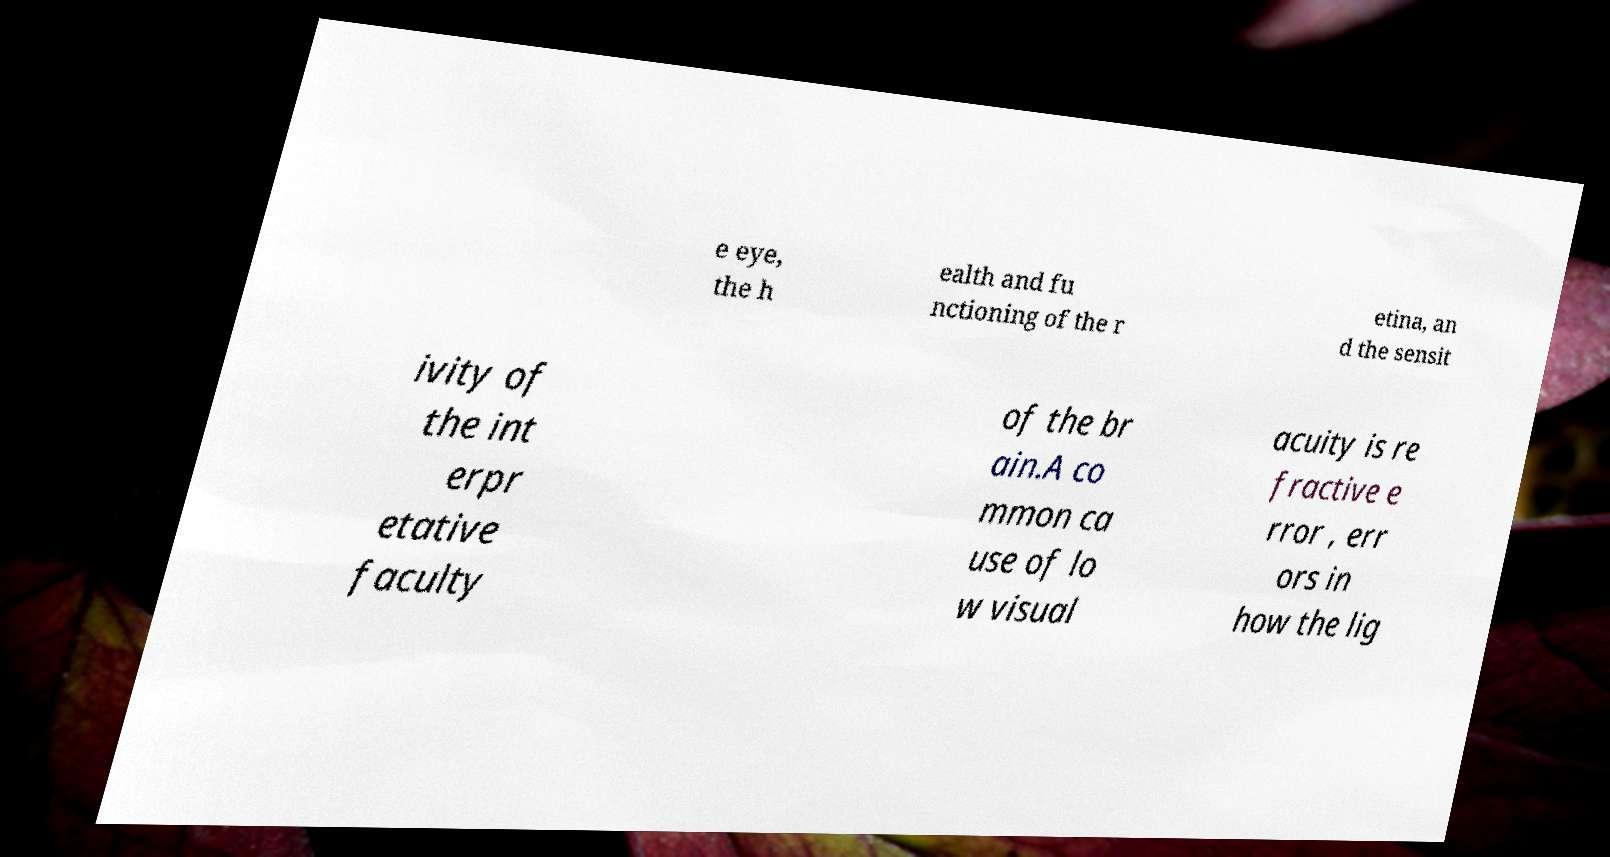Can you accurately transcribe the text from the provided image for me? e eye, the h ealth and fu nctioning of the r etina, an d the sensit ivity of the int erpr etative faculty of the br ain.A co mmon ca use of lo w visual acuity is re fractive e rror , err ors in how the lig 